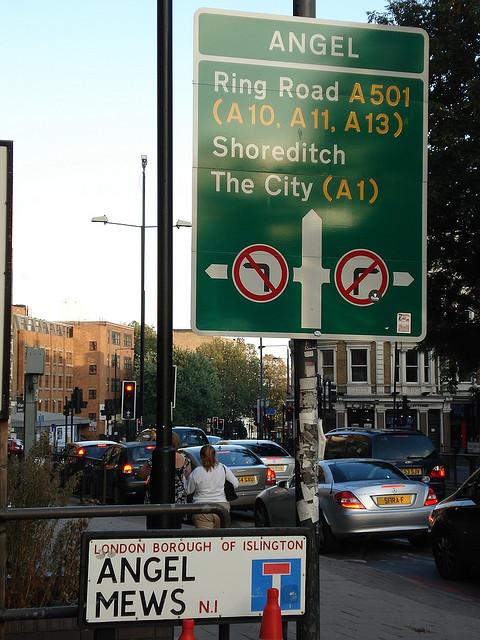What country is this photo located?
Keep it brief. England. Is the road busy?
Give a very brief answer. Yes. What color are the license plates?
Keep it brief. Yellow. Is there a truck in this picture?
Give a very brief answer. No. What is the name of the road?
Keep it brief. Ring road. 